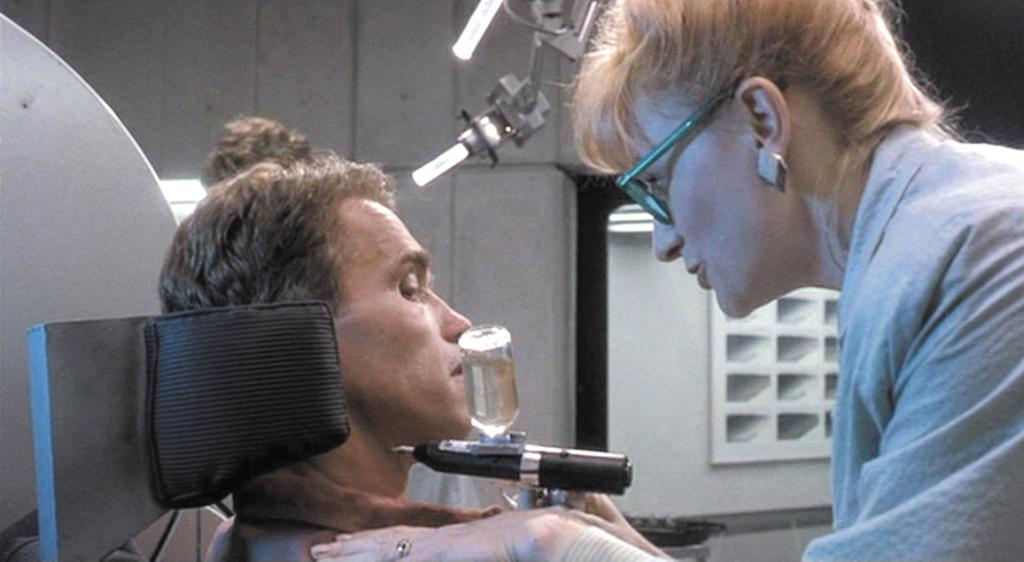What is the woman in the image wearing? The woman is wearing spectacles in the image. What is the woman holding in the image? The woman is holding a machine in the image. Can you describe the person sitting in the image? There is a person sitting in the image, but no specific details about their appearance or clothing are provided. What else can be seen in the image besides the woman and the person sitting? There is a machine and a wall in the background of the image. What type of coat is the horse wearing in the image? There is no horse or coat present in the image. 